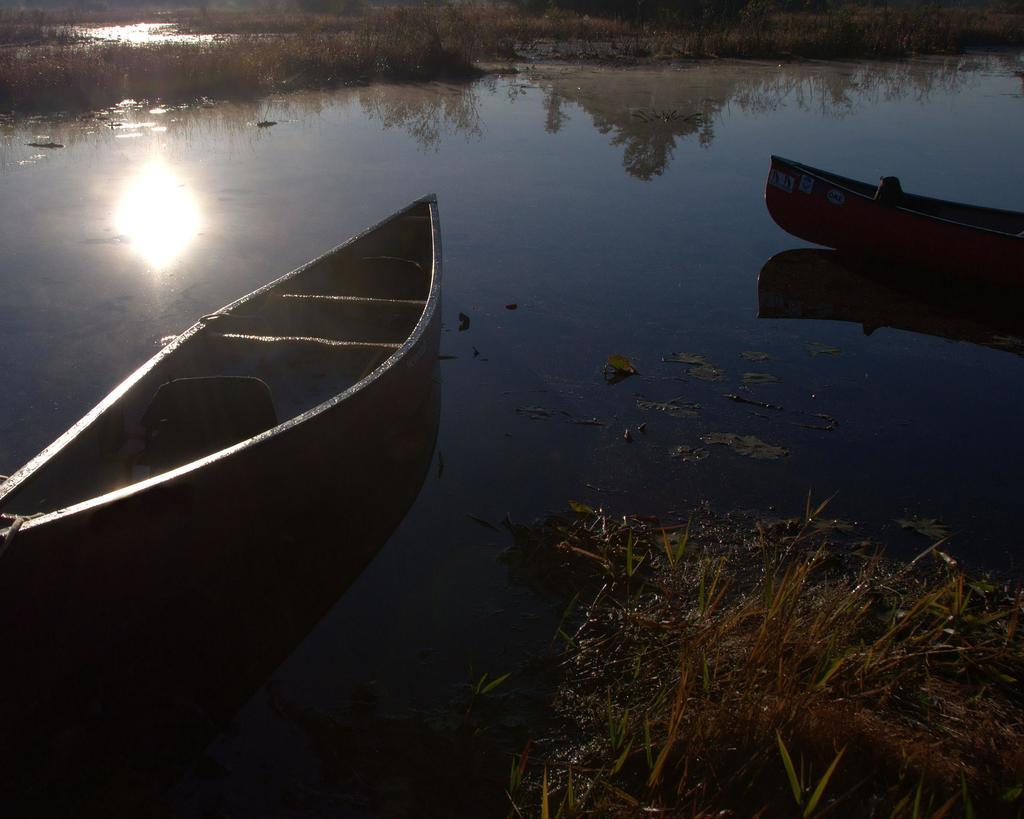What can be seen floating on the water in the image? There are two boats in the water in the image. What is the primary element visible in the image? Water is visible in the image. What can be observed in the water due to the presence of the sun? The reflection of the sun is visible in the water. What other reflection can be seen in the water? The reflection of a plant is visible in the water. What type of vegetation is present in the image? There is grass in the image. What type of bag is hanging from the tree in the image? There is no tree or bag present in the image; it features two boats in the water. 